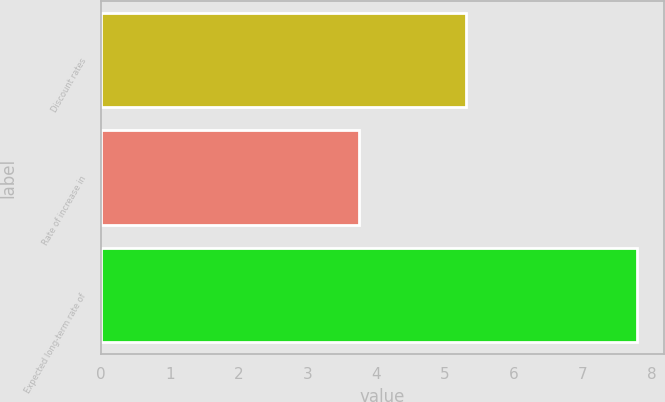Convert chart to OTSL. <chart><loc_0><loc_0><loc_500><loc_500><bar_chart><fcel>Discount rates<fcel>Rate of increase in<fcel>Expected long-term rate of<nl><fcel>5.3<fcel>3.75<fcel>7.79<nl></chart> 